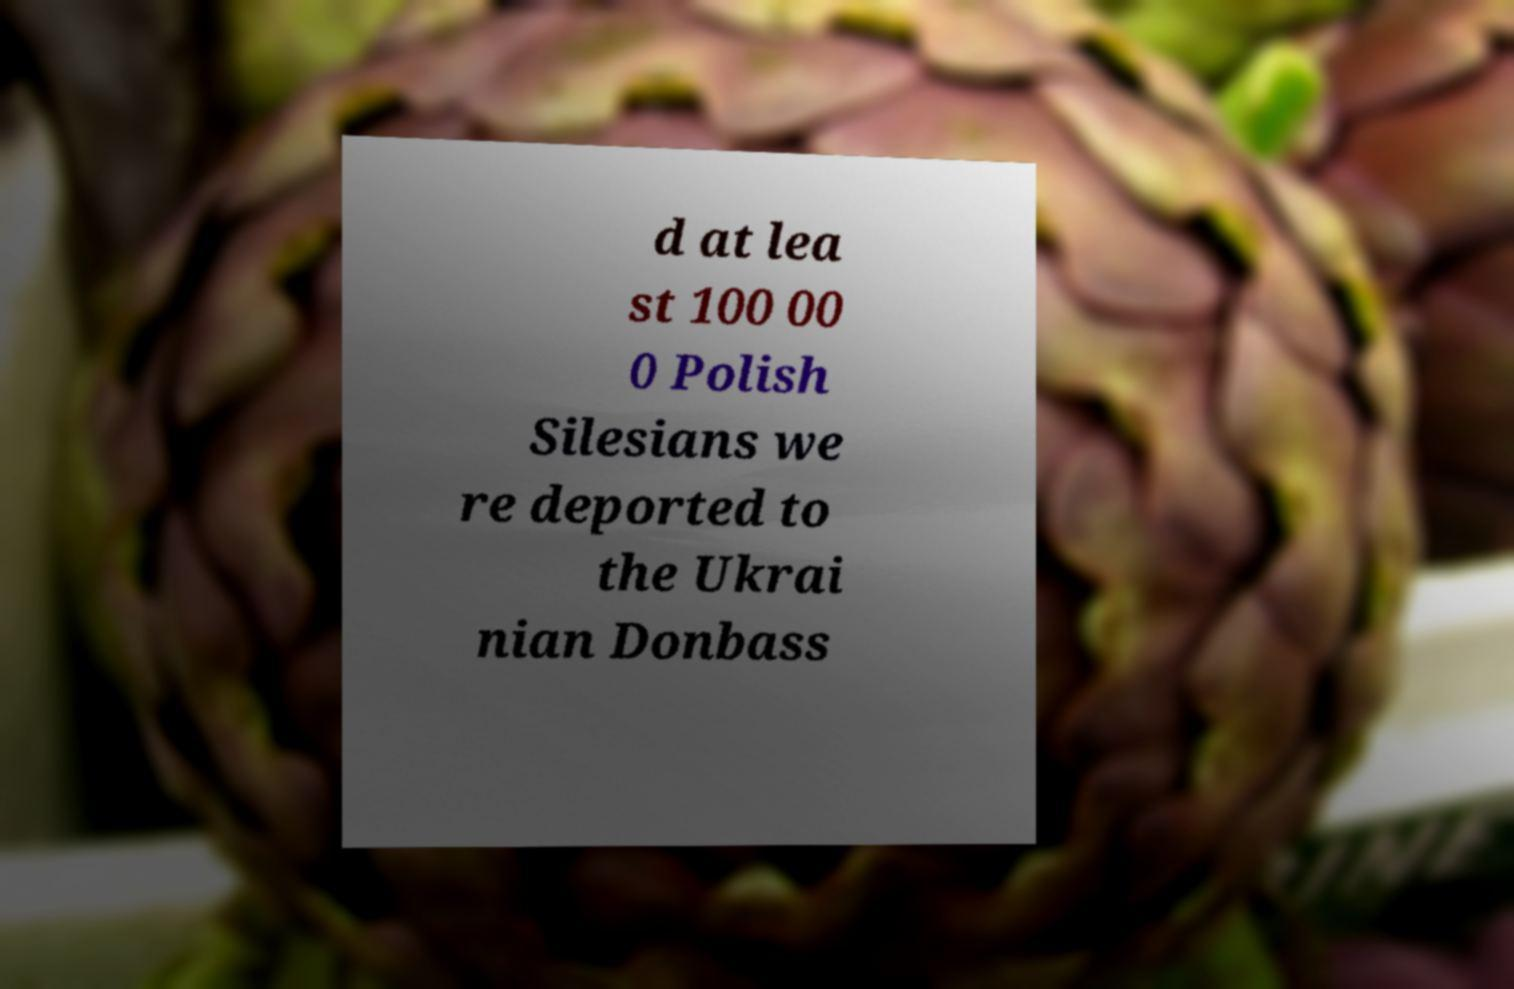Can you read and provide the text displayed in the image?This photo seems to have some interesting text. Can you extract and type it out for me? d at lea st 100 00 0 Polish Silesians we re deported to the Ukrai nian Donbass 